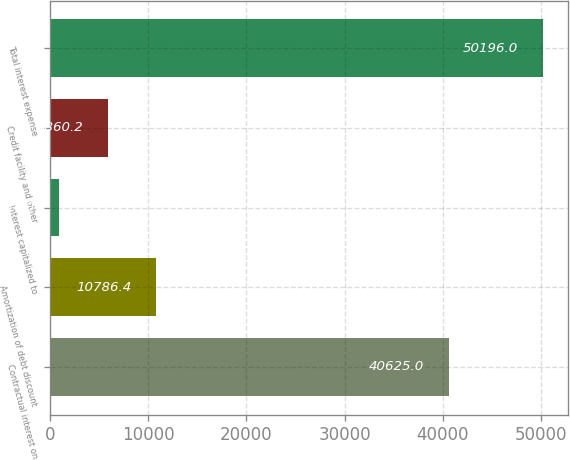Convert chart. <chart><loc_0><loc_0><loc_500><loc_500><bar_chart><fcel>Contractual interest on<fcel>Amortization of debt discount<fcel>Interest capitalized to<fcel>Credit facility and other<fcel>Total interest expense<nl><fcel>40625<fcel>10786.4<fcel>934<fcel>5860.2<fcel>50196<nl></chart> 